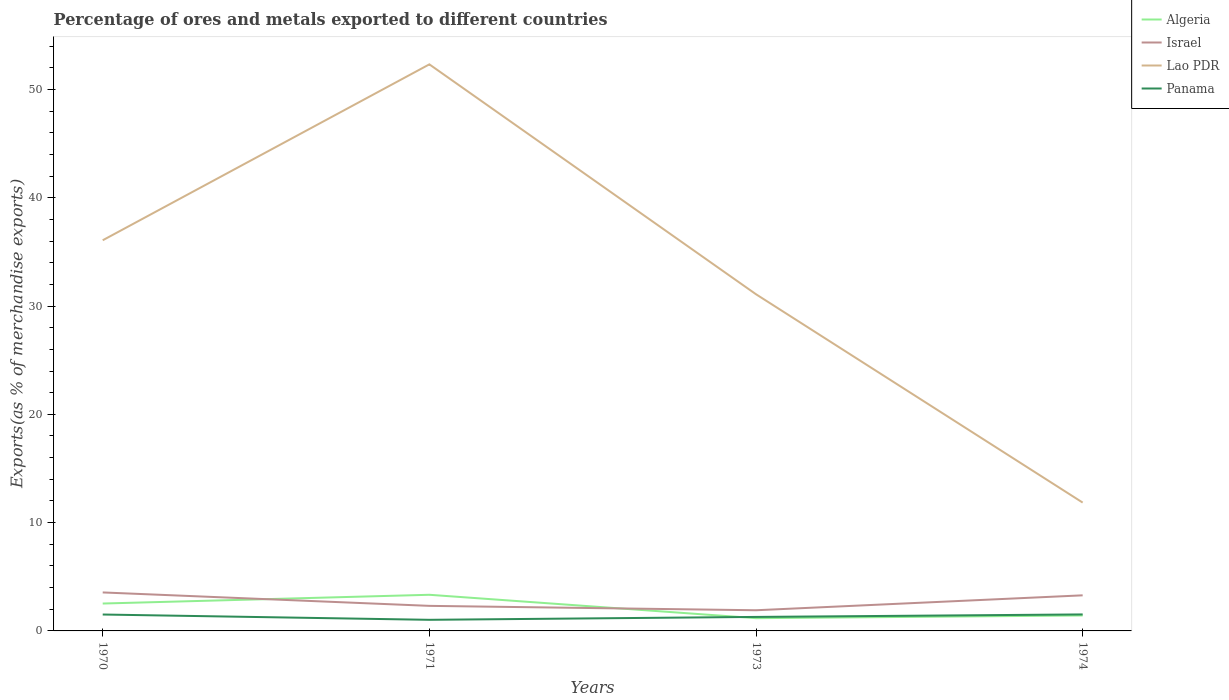Does the line corresponding to Panama intersect with the line corresponding to Israel?
Ensure brevity in your answer.  No. Across all years, what is the maximum percentage of exports to different countries in Panama?
Your answer should be compact. 1.03. In which year was the percentage of exports to different countries in Lao PDR maximum?
Offer a very short reply. 1974. What is the total percentage of exports to different countries in Israel in the graph?
Offer a terse response. 0.27. What is the difference between the highest and the second highest percentage of exports to different countries in Panama?
Make the answer very short. 0.5. What is the difference between the highest and the lowest percentage of exports to different countries in Lao PDR?
Your response must be concise. 2. Is the percentage of exports to different countries in Panama strictly greater than the percentage of exports to different countries in Israel over the years?
Provide a succinct answer. Yes. Does the graph contain any zero values?
Give a very brief answer. No. Where does the legend appear in the graph?
Keep it short and to the point. Top right. How many legend labels are there?
Provide a succinct answer. 4. What is the title of the graph?
Keep it short and to the point. Percentage of ores and metals exported to different countries. Does "Cyprus" appear as one of the legend labels in the graph?
Give a very brief answer. No. What is the label or title of the Y-axis?
Give a very brief answer. Exports(as % of merchandise exports). What is the Exports(as % of merchandise exports) of Algeria in 1970?
Your answer should be compact. 2.53. What is the Exports(as % of merchandise exports) of Israel in 1970?
Ensure brevity in your answer.  3.55. What is the Exports(as % of merchandise exports) in Lao PDR in 1970?
Offer a terse response. 36.07. What is the Exports(as % of merchandise exports) in Panama in 1970?
Ensure brevity in your answer.  1.52. What is the Exports(as % of merchandise exports) of Algeria in 1971?
Your response must be concise. 3.34. What is the Exports(as % of merchandise exports) of Israel in 1971?
Make the answer very short. 2.31. What is the Exports(as % of merchandise exports) of Lao PDR in 1971?
Provide a short and direct response. 52.32. What is the Exports(as % of merchandise exports) of Panama in 1971?
Your answer should be compact. 1.03. What is the Exports(as % of merchandise exports) in Algeria in 1973?
Provide a short and direct response. 1.18. What is the Exports(as % of merchandise exports) in Israel in 1973?
Your answer should be compact. 1.91. What is the Exports(as % of merchandise exports) in Lao PDR in 1973?
Your response must be concise. 31.09. What is the Exports(as % of merchandise exports) of Panama in 1973?
Provide a short and direct response. 1.29. What is the Exports(as % of merchandise exports) in Algeria in 1974?
Keep it short and to the point. 1.43. What is the Exports(as % of merchandise exports) in Israel in 1974?
Ensure brevity in your answer.  3.29. What is the Exports(as % of merchandise exports) in Lao PDR in 1974?
Your answer should be very brief. 11.85. What is the Exports(as % of merchandise exports) in Panama in 1974?
Ensure brevity in your answer.  1.52. Across all years, what is the maximum Exports(as % of merchandise exports) of Algeria?
Offer a terse response. 3.34. Across all years, what is the maximum Exports(as % of merchandise exports) of Israel?
Offer a terse response. 3.55. Across all years, what is the maximum Exports(as % of merchandise exports) in Lao PDR?
Your answer should be very brief. 52.32. Across all years, what is the maximum Exports(as % of merchandise exports) in Panama?
Offer a terse response. 1.52. Across all years, what is the minimum Exports(as % of merchandise exports) in Algeria?
Provide a succinct answer. 1.18. Across all years, what is the minimum Exports(as % of merchandise exports) in Israel?
Your answer should be very brief. 1.91. Across all years, what is the minimum Exports(as % of merchandise exports) of Lao PDR?
Your answer should be compact. 11.85. Across all years, what is the minimum Exports(as % of merchandise exports) of Panama?
Offer a very short reply. 1.03. What is the total Exports(as % of merchandise exports) in Algeria in the graph?
Ensure brevity in your answer.  8.47. What is the total Exports(as % of merchandise exports) in Israel in the graph?
Offer a very short reply. 11.06. What is the total Exports(as % of merchandise exports) in Lao PDR in the graph?
Your answer should be compact. 131.32. What is the total Exports(as % of merchandise exports) in Panama in the graph?
Your answer should be very brief. 5.36. What is the difference between the Exports(as % of merchandise exports) of Algeria in 1970 and that in 1971?
Keep it short and to the point. -0.81. What is the difference between the Exports(as % of merchandise exports) in Israel in 1970 and that in 1971?
Offer a terse response. 1.24. What is the difference between the Exports(as % of merchandise exports) in Lao PDR in 1970 and that in 1971?
Offer a terse response. -16.24. What is the difference between the Exports(as % of merchandise exports) of Panama in 1970 and that in 1971?
Your response must be concise. 0.49. What is the difference between the Exports(as % of merchandise exports) of Algeria in 1970 and that in 1973?
Your response must be concise. 1.35. What is the difference between the Exports(as % of merchandise exports) of Israel in 1970 and that in 1973?
Your answer should be very brief. 1.64. What is the difference between the Exports(as % of merchandise exports) of Lao PDR in 1970 and that in 1973?
Ensure brevity in your answer.  4.98. What is the difference between the Exports(as % of merchandise exports) in Panama in 1970 and that in 1973?
Your answer should be compact. 0.22. What is the difference between the Exports(as % of merchandise exports) in Algeria in 1970 and that in 1974?
Offer a very short reply. 1.1. What is the difference between the Exports(as % of merchandise exports) in Israel in 1970 and that in 1974?
Your answer should be compact. 0.27. What is the difference between the Exports(as % of merchandise exports) in Lao PDR in 1970 and that in 1974?
Your answer should be compact. 24.22. What is the difference between the Exports(as % of merchandise exports) in Panama in 1970 and that in 1974?
Keep it short and to the point. -0.01. What is the difference between the Exports(as % of merchandise exports) of Algeria in 1971 and that in 1973?
Provide a short and direct response. 2.16. What is the difference between the Exports(as % of merchandise exports) of Israel in 1971 and that in 1973?
Provide a short and direct response. 0.4. What is the difference between the Exports(as % of merchandise exports) of Lao PDR in 1971 and that in 1973?
Your response must be concise. 21.23. What is the difference between the Exports(as % of merchandise exports) in Panama in 1971 and that in 1973?
Make the answer very short. -0.27. What is the difference between the Exports(as % of merchandise exports) in Algeria in 1971 and that in 1974?
Keep it short and to the point. 1.91. What is the difference between the Exports(as % of merchandise exports) of Israel in 1971 and that in 1974?
Your answer should be very brief. -0.97. What is the difference between the Exports(as % of merchandise exports) of Lao PDR in 1971 and that in 1974?
Your answer should be compact. 40.47. What is the difference between the Exports(as % of merchandise exports) in Panama in 1971 and that in 1974?
Offer a very short reply. -0.5. What is the difference between the Exports(as % of merchandise exports) in Algeria in 1973 and that in 1974?
Keep it short and to the point. -0.25. What is the difference between the Exports(as % of merchandise exports) of Israel in 1973 and that in 1974?
Offer a very short reply. -1.38. What is the difference between the Exports(as % of merchandise exports) of Lao PDR in 1973 and that in 1974?
Provide a succinct answer. 19.24. What is the difference between the Exports(as % of merchandise exports) of Panama in 1973 and that in 1974?
Your answer should be compact. -0.23. What is the difference between the Exports(as % of merchandise exports) of Algeria in 1970 and the Exports(as % of merchandise exports) of Israel in 1971?
Make the answer very short. 0.22. What is the difference between the Exports(as % of merchandise exports) in Algeria in 1970 and the Exports(as % of merchandise exports) in Lao PDR in 1971?
Your answer should be very brief. -49.79. What is the difference between the Exports(as % of merchandise exports) of Algeria in 1970 and the Exports(as % of merchandise exports) of Panama in 1971?
Keep it short and to the point. 1.5. What is the difference between the Exports(as % of merchandise exports) of Israel in 1970 and the Exports(as % of merchandise exports) of Lao PDR in 1971?
Give a very brief answer. -48.76. What is the difference between the Exports(as % of merchandise exports) in Israel in 1970 and the Exports(as % of merchandise exports) in Panama in 1971?
Keep it short and to the point. 2.53. What is the difference between the Exports(as % of merchandise exports) of Lao PDR in 1970 and the Exports(as % of merchandise exports) of Panama in 1971?
Provide a succinct answer. 35.05. What is the difference between the Exports(as % of merchandise exports) of Algeria in 1970 and the Exports(as % of merchandise exports) of Israel in 1973?
Provide a short and direct response. 0.62. What is the difference between the Exports(as % of merchandise exports) of Algeria in 1970 and the Exports(as % of merchandise exports) of Lao PDR in 1973?
Ensure brevity in your answer.  -28.56. What is the difference between the Exports(as % of merchandise exports) in Algeria in 1970 and the Exports(as % of merchandise exports) in Panama in 1973?
Provide a succinct answer. 1.24. What is the difference between the Exports(as % of merchandise exports) in Israel in 1970 and the Exports(as % of merchandise exports) in Lao PDR in 1973?
Your answer should be very brief. -27.53. What is the difference between the Exports(as % of merchandise exports) in Israel in 1970 and the Exports(as % of merchandise exports) in Panama in 1973?
Your response must be concise. 2.26. What is the difference between the Exports(as % of merchandise exports) in Lao PDR in 1970 and the Exports(as % of merchandise exports) in Panama in 1973?
Offer a very short reply. 34.78. What is the difference between the Exports(as % of merchandise exports) of Algeria in 1970 and the Exports(as % of merchandise exports) of Israel in 1974?
Offer a terse response. -0.76. What is the difference between the Exports(as % of merchandise exports) of Algeria in 1970 and the Exports(as % of merchandise exports) of Lao PDR in 1974?
Give a very brief answer. -9.32. What is the difference between the Exports(as % of merchandise exports) of Israel in 1970 and the Exports(as % of merchandise exports) of Lao PDR in 1974?
Your response must be concise. -8.3. What is the difference between the Exports(as % of merchandise exports) of Israel in 1970 and the Exports(as % of merchandise exports) of Panama in 1974?
Offer a terse response. 2.03. What is the difference between the Exports(as % of merchandise exports) in Lao PDR in 1970 and the Exports(as % of merchandise exports) in Panama in 1974?
Provide a succinct answer. 34.55. What is the difference between the Exports(as % of merchandise exports) of Algeria in 1971 and the Exports(as % of merchandise exports) of Israel in 1973?
Provide a succinct answer. 1.43. What is the difference between the Exports(as % of merchandise exports) in Algeria in 1971 and the Exports(as % of merchandise exports) in Lao PDR in 1973?
Your response must be concise. -27.75. What is the difference between the Exports(as % of merchandise exports) of Algeria in 1971 and the Exports(as % of merchandise exports) of Panama in 1973?
Your response must be concise. 2.04. What is the difference between the Exports(as % of merchandise exports) of Israel in 1971 and the Exports(as % of merchandise exports) of Lao PDR in 1973?
Give a very brief answer. -28.77. What is the difference between the Exports(as % of merchandise exports) of Israel in 1971 and the Exports(as % of merchandise exports) of Panama in 1973?
Your answer should be compact. 1.02. What is the difference between the Exports(as % of merchandise exports) of Lao PDR in 1971 and the Exports(as % of merchandise exports) of Panama in 1973?
Your answer should be very brief. 51.02. What is the difference between the Exports(as % of merchandise exports) of Algeria in 1971 and the Exports(as % of merchandise exports) of Israel in 1974?
Offer a very short reply. 0.05. What is the difference between the Exports(as % of merchandise exports) in Algeria in 1971 and the Exports(as % of merchandise exports) in Lao PDR in 1974?
Offer a terse response. -8.51. What is the difference between the Exports(as % of merchandise exports) of Algeria in 1971 and the Exports(as % of merchandise exports) of Panama in 1974?
Your answer should be very brief. 1.81. What is the difference between the Exports(as % of merchandise exports) of Israel in 1971 and the Exports(as % of merchandise exports) of Lao PDR in 1974?
Provide a succinct answer. -9.54. What is the difference between the Exports(as % of merchandise exports) of Israel in 1971 and the Exports(as % of merchandise exports) of Panama in 1974?
Provide a short and direct response. 0.79. What is the difference between the Exports(as % of merchandise exports) of Lao PDR in 1971 and the Exports(as % of merchandise exports) of Panama in 1974?
Give a very brief answer. 50.79. What is the difference between the Exports(as % of merchandise exports) of Algeria in 1973 and the Exports(as % of merchandise exports) of Israel in 1974?
Give a very brief answer. -2.11. What is the difference between the Exports(as % of merchandise exports) in Algeria in 1973 and the Exports(as % of merchandise exports) in Lao PDR in 1974?
Offer a very short reply. -10.67. What is the difference between the Exports(as % of merchandise exports) in Algeria in 1973 and the Exports(as % of merchandise exports) in Panama in 1974?
Ensure brevity in your answer.  -0.35. What is the difference between the Exports(as % of merchandise exports) of Israel in 1973 and the Exports(as % of merchandise exports) of Lao PDR in 1974?
Your answer should be very brief. -9.94. What is the difference between the Exports(as % of merchandise exports) of Israel in 1973 and the Exports(as % of merchandise exports) of Panama in 1974?
Provide a short and direct response. 0.38. What is the difference between the Exports(as % of merchandise exports) of Lao PDR in 1973 and the Exports(as % of merchandise exports) of Panama in 1974?
Provide a succinct answer. 29.56. What is the average Exports(as % of merchandise exports) in Algeria per year?
Provide a short and direct response. 2.12. What is the average Exports(as % of merchandise exports) of Israel per year?
Make the answer very short. 2.77. What is the average Exports(as % of merchandise exports) in Lao PDR per year?
Provide a succinct answer. 32.83. What is the average Exports(as % of merchandise exports) of Panama per year?
Offer a very short reply. 1.34. In the year 1970, what is the difference between the Exports(as % of merchandise exports) of Algeria and Exports(as % of merchandise exports) of Israel?
Ensure brevity in your answer.  -1.02. In the year 1970, what is the difference between the Exports(as % of merchandise exports) in Algeria and Exports(as % of merchandise exports) in Lao PDR?
Provide a succinct answer. -33.54. In the year 1970, what is the difference between the Exports(as % of merchandise exports) of Algeria and Exports(as % of merchandise exports) of Panama?
Your response must be concise. 1.01. In the year 1970, what is the difference between the Exports(as % of merchandise exports) of Israel and Exports(as % of merchandise exports) of Lao PDR?
Provide a succinct answer. -32.52. In the year 1970, what is the difference between the Exports(as % of merchandise exports) in Israel and Exports(as % of merchandise exports) in Panama?
Your answer should be very brief. 2.04. In the year 1970, what is the difference between the Exports(as % of merchandise exports) in Lao PDR and Exports(as % of merchandise exports) in Panama?
Provide a succinct answer. 34.56. In the year 1971, what is the difference between the Exports(as % of merchandise exports) of Algeria and Exports(as % of merchandise exports) of Israel?
Provide a short and direct response. 1.02. In the year 1971, what is the difference between the Exports(as % of merchandise exports) of Algeria and Exports(as % of merchandise exports) of Lao PDR?
Your answer should be compact. -48.98. In the year 1971, what is the difference between the Exports(as % of merchandise exports) in Algeria and Exports(as % of merchandise exports) in Panama?
Your answer should be very brief. 2.31. In the year 1971, what is the difference between the Exports(as % of merchandise exports) in Israel and Exports(as % of merchandise exports) in Lao PDR?
Provide a short and direct response. -50. In the year 1971, what is the difference between the Exports(as % of merchandise exports) of Israel and Exports(as % of merchandise exports) of Panama?
Give a very brief answer. 1.29. In the year 1971, what is the difference between the Exports(as % of merchandise exports) in Lao PDR and Exports(as % of merchandise exports) in Panama?
Make the answer very short. 51.29. In the year 1973, what is the difference between the Exports(as % of merchandise exports) of Algeria and Exports(as % of merchandise exports) of Israel?
Offer a terse response. -0.73. In the year 1973, what is the difference between the Exports(as % of merchandise exports) in Algeria and Exports(as % of merchandise exports) in Lao PDR?
Ensure brevity in your answer.  -29.91. In the year 1973, what is the difference between the Exports(as % of merchandise exports) in Algeria and Exports(as % of merchandise exports) in Panama?
Offer a very short reply. -0.12. In the year 1973, what is the difference between the Exports(as % of merchandise exports) in Israel and Exports(as % of merchandise exports) in Lao PDR?
Make the answer very short. -29.18. In the year 1973, what is the difference between the Exports(as % of merchandise exports) of Israel and Exports(as % of merchandise exports) of Panama?
Keep it short and to the point. 0.62. In the year 1973, what is the difference between the Exports(as % of merchandise exports) in Lao PDR and Exports(as % of merchandise exports) in Panama?
Your response must be concise. 29.79. In the year 1974, what is the difference between the Exports(as % of merchandise exports) of Algeria and Exports(as % of merchandise exports) of Israel?
Provide a succinct answer. -1.86. In the year 1974, what is the difference between the Exports(as % of merchandise exports) in Algeria and Exports(as % of merchandise exports) in Lao PDR?
Your answer should be compact. -10.42. In the year 1974, what is the difference between the Exports(as % of merchandise exports) in Algeria and Exports(as % of merchandise exports) in Panama?
Offer a terse response. -0.1. In the year 1974, what is the difference between the Exports(as % of merchandise exports) of Israel and Exports(as % of merchandise exports) of Lao PDR?
Your answer should be very brief. -8.56. In the year 1974, what is the difference between the Exports(as % of merchandise exports) of Israel and Exports(as % of merchandise exports) of Panama?
Give a very brief answer. 1.76. In the year 1974, what is the difference between the Exports(as % of merchandise exports) in Lao PDR and Exports(as % of merchandise exports) in Panama?
Ensure brevity in your answer.  10.33. What is the ratio of the Exports(as % of merchandise exports) in Algeria in 1970 to that in 1971?
Ensure brevity in your answer.  0.76. What is the ratio of the Exports(as % of merchandise exports) in Israel in 1970 to that in 1971?
Keep it short and to the point. 1.54. What is the ratio of the Exports(as % of merchandise exports) in Lao PDR in 1970 to that in 1971?
Offer a terse response. 0.69. What is the ratio of the Exports(as % of merchandise exports) in Panama in 1970 to that in 1971?
Provide a succinct answer. 1.48. What is the ratio of the Exports(as % of merchandise exports) in Algeria in 1970 to that in 1973?
Offer a very short reply. 2.15. What is the ratio of the Exports(as % of merchandise exports) of Israel in 1970 to that in 1973?
Your response must be concise. 1.86. What is the ratio of the Exports(as % of merchandise exports) of Lao PDR in 1970 to that in 1973?
Offer a very short reply. 1.16. What is the ratio of the Exports(as % of merchandise exports) of Panama in 1970 to that in 1973?
Provide a succinct answer. 1.17. What is the ratio of the Exports(as % of merchandise exports) in Algeria in 1970 to that in 1974?
Keep it short and to the point. 1.77. What is the ratio of the Exports(as % of merchandise exports) of Israel in 1970 to that in 1974?
Offer a very short reply. 1.08. What is the ratio of the Exports(as % of merchandise exports) in Lao PDR in 1970 to that in 1974?
Your response must be concise. 3.04. What is the ratio of the Exports(as % of merchandise exports) in Panama in 1970 to that in 1974?
Your response must be concise. 0.99. What is the ratio of the Exports(as % of merchandise exports) of Algeria in 1971 to that in 1973?
Give a very brief answer. 2.84. What is the ratio of the Exports(as % of merchandise exports) of Israel in 1971 to that in 1973?
Make the answer very short. 1.21. What is the ratio of the Exports(as % of merchandise exports) in Lao PDR in 1971 to that in 1973?
Offer a terse response. 1.68. What is the ratio of the Exports(as % of merchandise exports) of Panama in 1971 to that in 1973?
Offer a very short reply. 0.79. What is the ratio of the Exports(as % of merchandise exports) of Algeria in 1971 to that in 1974?
Offer a very short reply. 2.34. What is the ratio of the Exports(as % of merchandise exports) of Israel in 1971 to that in 1974?
Your answer should be compact. 0.7. What is the ratio of the Exports(as % of merchandise exports) in Lao PDR in 1971 to that in 1974?
Your response must be concise. 4.41. What is the ratio of the Exports(as % of merchandise exports) in Panama in 1971 to that in 1974?
Keep it short and to the point. 0.67. What is the ratio of the Exports(as % of merchandise exports) of Algeria in 1973 to that in 1974?
Your answer should be very brief. 0.82. What is the ratio of the Exports(as % of merchandise exports) in Israel in 1973 to that in 1974?
Make the answer very short. 0.58. What is the ratio of the Exports(as % of merchandise exports) of Lao PDR in 1973 to that in 1974?
Ensure brevity in your answer.  2.62. What is the ratio of the Exports(as % of merchandise exports) in Panama in 1973 to that in 1974?
Ensure brevity in your answer.  0.85. What is the difference between the highest and the second highest Exports(as % of merchandise exports) in Algeria?
Ensure brevity in your answer.  0.81. What is the difference between the highest and the second highest Exports(as % of merchandise exports) of Israel?
Make the answer very short. 0.27. What is the difference between the highest and the second highest Exports(as % of merchandise exports) in Lao PDR?
Give a very brief answer. 16.24. What is the difference between the highest and the second highest Exports(as % of merchandise exports) of Panama?
Provide a short and direct response. 0.01. What is the difference between the highest and the lowest Exports(as % of merchandise exports) in Algeria?
Offer a very short reply. 2.16. What is the difference between the highest and the lowest Exports(as % of merchandise exports) of Israel?
Give a very brief answer. 1.64. What is the difference between the highest and the lowest Exports(as % of merchandise exports) in Lao PDR?
Provide a succinct answer. 40.47. What is the difference between the highest and the lowest Exports(as % of merchandise exports) in Panama?
Ensure brevity in your answer.  0.5. 